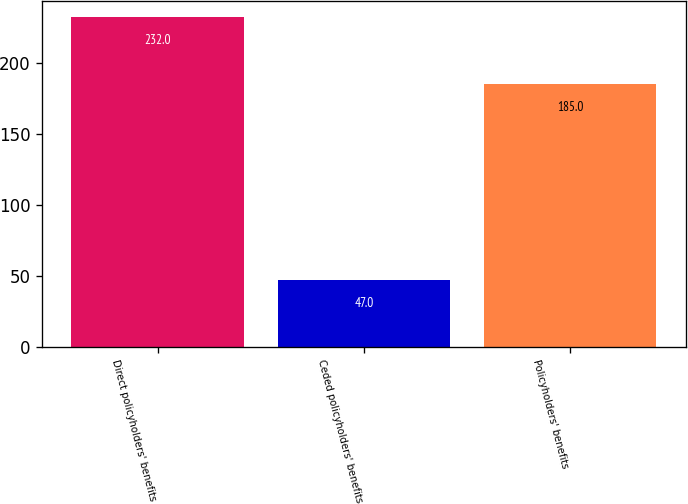Convert chart. <chart><loc_0><loc_0><loc_500><loc_500><bar_chart><fcel>Direct policyholders' benefits<fcel>Ceded policyholders' benefits<fcel>Policyholders' benefits<nl><fcel>232<fcel>47<fcel>185<nl></chart> 